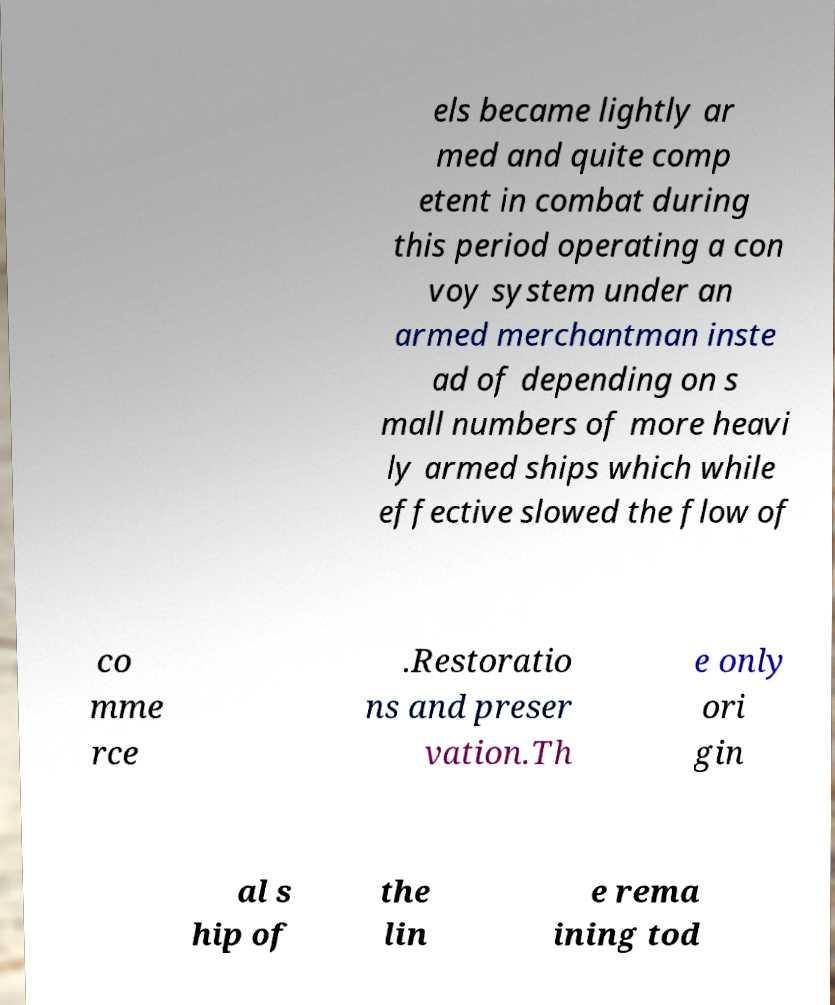What messages or text are displayed in this image? I need them in a readable, typed format. els became lightly ar med and quite comp etent in combat during this period operating a con voy system under an armed merchantman inste ad of depending on s mall numbers of more heavi ly armed ships which while effective slowed the flow of co mme rce .Restoratio ns and preser vation.Th e only ori gin al s hip of the lin e rema ining tod 